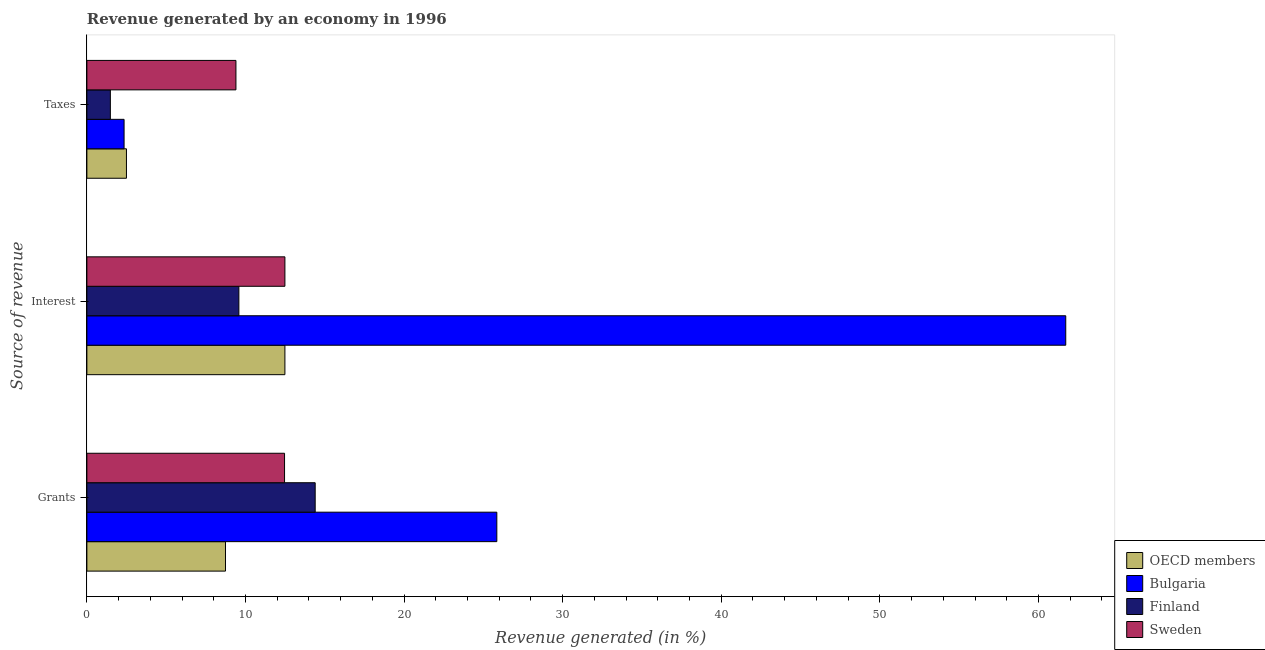How many groups of bars are there?
Your response must be concise. 3. Are the number of bars per tick equal to the number of legend labels?
Offer a very short reply. Yes. Are the number of bars on each tick of the Y-axis equal?
Your answer should be very brief. Yes. How many bars are there on the 1st tick from the top?
Your answer should be compact. 4. How many bars are there on the 1st tick from the bottom?
Your answer should be very brief. 4. What is the label of the 2nd group of bars from the top?
Make the answer very short. Interest. What is the percentage of revenue generated by grants in Sweden?
Give a very brief answer. 12.46. Across all countries, what is the maximum percentage of revenue generated by interest?
Offer a terse response. 61.72. Across all countries, what is the minimum percentage of revenue generated by taxes?
Offer a terse response. 1.48. In which country was the percentage of revenue generated by grants minimum?
Your response must be concise. OECD members. What is the total percentage of revenue generated by interest in the graph?
Provide a short and direct response. 96.28. What is the difference between the percentage of revenue generated by grants in OECD members and that in Sweden?
Your answer should be compact. -3.72. What is the difference between the percentage of revenue generated by interest in Sweden and the percentage of revenue generated by grants in Finland?
Give a very brief answer. -1.91. What is the average percentage of revenue generated by taxes per country?
Provide a short and direct response. 3.93. What is the difference between the percentage of revenue generated by grants and percentage of revenue generated by taxes in Bulgaria?
Your response must be concise. 23.5. What is the ratio of the percentage of revenue generated by grants in Sweden to that in Finland?
Offer a very short reply. 0.87. What is the difference between the highest and the second highest percentage of revenue generated by taxes?
Keep it short and to the point. 6.9. What is the difference between the highest and the lowest percentage of revenue generated by taxes?
Offer a terse response. 7.92. What does the 1st bar from the top in Grants represents?
Give a very brief answer. Sweden. Is it the case that in every country, the sum of the percentage of revenue generated by grants and percentage of revenue generated by interest is greater than the percentage of revenue generated by taxes?
Provide a short and direct response. Yes. How many bars are there?
Offer a very short reply. 12. Are all the bars in the graph horizontal?
Offer a terse response. Yes. How many countries are there in the graph?
Your answer should be compact. 4. Are the values on the major ticks of X-axis written in scientific E-notation?
Offer a very short reply. No. Does the graph contain any zero values?
Provide a short and direct response. No. How many legend labels are there?
Your response must be concise. 4. How are the legend labels stacked?
Keep it short and to the point. Vertical. What is the title of the graph?
Your answer should be compact. Revenue generated by an economy in 1996. What is the label or title of the X-axis?
Keep it short and to the point. Revenue generated (in %). What is the label or title of the Y-axis?
Offer a very short reply. Source of revenue. What is the Revenue generated (in %) of OECD members in Grants?
Your response must be concise. 8.74. What is the Revenue generated (in %) of Bulgaria in Grants?
Give a very brief answer. 25.85. What is the Revenue generated (in %) of Finland in Grants?
Offer a very short reply. 14.4. What is the Revenue generated (in %) of Sweden in Grants?
Keep it short and to the point. 12.46. What is the Revenue generated (in %) in OECD members in Interest?
Your answer should be compact. 12.49. What is the Revenue generated (in %) in Bulgaria in Interest?
Your answer should be compact. 61.72. What is the Revenue generated (in %) in Finland in Interest?
Your response must be concise. 9.58. What is the Revenue generated (in %) in Sweden in Interest?
Your answer should be very brief. 12.49. What is the Revenue generated (in %) of OECD members in Taxes?
Give a very brief answer. 2.5. What is the Revenue generated (in %) in Bulgaria in Taxes?
Your answer should be compact. 2.35. What is the Revenue generated (in %) of Finland in Taxes?
Provide a short and direct response. 1.48. What is the Revenue generated (in %) of Sweden in Taxes?
Ensure brevity in your answer.  9.4. Across all Source of revenue, what is the maximum Revenue generated (in %) of OECD members?
Keep it short and to the point. 12.49. Across all Source of revenue, what is the maximum Revenue generated (in %) in Bulgaria?
Provide a succinct answer. 61.72. Across all Source of revenue, what is the maximum Revenue generated (in %) of Finland?
Ensure brevity in your answer.  14.4. Across all Source of revenue, what is the maximum Revenue generated (in %) in Sweden?
Provide a succinct answer. 12.49. Across all Source of revenue, what is the minimum Revenue generated (in %) of OECD members?
Give a very brief answer. 2.5. Across all Source of revenue, what is the minimum Revenue generated (in %) in Bulgaria?
Your answer should be very brief. 2.35. Across all Source of revenue, what is the minimum Revenue generated (in %) of Finland?
Your response must be concise. 1.48. Across all Source of revenue, what is the minimum Revenue generated (in %) of Sweden?
Your answer should be very brief. 9.4. What is the total Revenue generated (in %) in OECD members in the graph?
Offer a terse response. 23.72. What is the total Revenue generated (in %) in Bulgaria in the graph?
Ensure brevity in your answer.  89.92. What is the total Revenue generated (in %) of Finland in the graph?
Your answer should be compact. 25.46. What is the total Revenue generated (in %) in Sweden in the graph?
Your response must be concise. 34.35. What is the difference between the Revenue generated (in %) of OECD members in Grants and that in Interest?
Ensure brevity in your answer.  -3.75. What is the difference between the Revenue generated (in %) of Bulgaria in Grants and that in Interest?
Ensure brevity in your answer.  -35.87. What is the difference between the Revenue generated (in %) of Finland in Grants and that in Interest?
Ensure brevity in your answer.  4.81. What is the difference between the Revenue generated (in %) of Sweden in Grants and that in Interest?
Provide a succinct answer. -0.02. What is the difference between the Revenue generated (in %) of OECD members in Grants and that in Taxes?
Your answer should be compact. 6.24. What is the difference between the Revenue generated (in %) in Bulgaria in Grants and that in Taxes?
Make the answer very short. 23.5. What is the difference between the Revenue generated (in %) of Finland in Grants and that in Taxes?
Give a very brief answer. 12.91. What is the difference between the Revenue generated (in %) in Sweden in Grants and that in Taxes?
Ensure brevity in your answer.  3.06. What is the difference between the Revenue generated (in %) in OECD members in Interest and that in Taxes?
Your answer should be compact. 9.99. What is the difference between the Revenue generated (in %) in Bulgaria in Interest and that in Taxes?
Make the answer very short. 59.38. What is the difference between the Revenue generated (in %) in Finland in Interest and that in Taxes?
Offer a very short reply. 8.1. What is the difference between the Revenue generated (in %) of Sweden in Interest and that in Taxes?
Your answer should be compact. 3.09. What is the difference between the Revenue generated (in %) of OECD members in Grants and the Revenue generated (in %) of Bulgaria in Interest?
Provide a succinct answer. -52.98. What is the difference between the Revenue generated (in %) of OECD members in Grants and the Revenue generated (in %) of Finland in Interest?
Your answer should be very brief. -0.84. What is the difference between the Revenue generated (in %) in OECD members in Grants and the Revenue generated (in %) in Sweden in Interest?
Your response must be concise. -3.75. What is the difference between the Revenue generated (in %) of Bulgaria in Grants and the Revenue generated (in %) of Finland in Interest?
Keep it short and to the point. 16.26. What is the difference between the Revenue generated (in %) of Bulgaria in Grants and the Revenue generated (in %) of Sweden in Interest?
Provide a succinct answer. 13.36. What is the difference between the Revenue generated (in %) of Finland in Grants and the Revenue generated (in %) of Sweden in Interest?
Make the answer very short. 1.91. What is the difference between the Revenue generated (in %) of OECD members in Grants and the Revenue generated (in %) of Bulgaria in Taxes?
Your answer should be very brief. 6.39. What is the difference between the Revenue generated (in %) of OECD members in Grants and the Revenue generated (in %) of Finland in Taxes?
Offer a terse response. 7.26. What is the difference between the Revenue generated (in %) in OECD members in Grants and the Revenue generated (in %) in Sweden in Taxes?
Your answer should be very brief. -0.66. What is the difference between the Revenue generated (in %) in Bulgaria in Grants and the Revenue generated (in %) in Finland in Taxes?
Your response must be concise. 24.37. What is the difference between the Revenue generated (in %) of Bulgaria in Grants and the Revenue generated (in %) of Sweden in Taxes?
Your answer should be compact. 16.45. What is the difference between the Revenue generated (in %) of Finland in Grants and the Revenue generated (in %) of Sweden in Taxes?
Give a very brief answer. 5. What is the difference between the Revenue generated (in %) of OECD members in Interest and the Revenue generated (in %) of Bulgaria in Taxes?
Provide a succinct answer. 10.14. What is the difference between the Revenue generated (in %) of OECD members in Interest and the Revenue generated (in %) of Finland in Taxes?
Your answer should be very brief. 11.01. What is the difference between the Revenue generated (in %) of OECD members in Interest and the Revenue generated (in %) of Sweden in Taxes?
Ensure brevity in your answer.  3.09. What is the difference between the Revenue generated (in %) of Bulgaria in Interest and the Revenue generated (in %) of Finland in Taxes?
Ensure brevity in your answer.  60.24. What is the difference between the Revenue generated (in %) of Bulgaria in Interest and the Revenue generated (in %) of Sweden in Taxes?
Offer a terse response. 52.32. What is the difference between the Revenue generated (in %) in Finland in Interest and the Revenue generated (in %) in Sweden in Taxes?
Your response must be concise. 0.19. What is the average Revenue generated (in %) of OECD members per Source of revenue?
Provide a short and direct response. 7.91. What is the average Revenue generated (in %) of Bulgaria per Source of revenue?
Your answer should be compact. 29.97. What is the average Revenue generated (in %) in Finland per Source of revenue?
Keep it short and to the point. 8.49. What is the average Revenue generated (in %) of Sweden per Source of revenue?
Give a very brief answer. 11.45. What is the difference between the Revenue generated (in %) of OECD members and Revenue generated (in %) of Bulgaria in Grants?
Provide a succinct answer. -17.11. What is the difference between the Revenue generated (in %) of OECD members and Revenue generated (in %) of Finland in Grants?
Make the answer very short. -5.66. What is the difference between the Revenue generated (in %) in OECD members and Revenue generated (in %) in Sweden in Grants?
Offer a very short reply. -3.72. What is the difference between the Revenue generated (in %) of Bulgaria and Revenue generated (in %) of Finland in Grants?
Give a very brief answer. 11.45. What is the difference between the Revenue generated (in %) in Bulgaria and Revenue generated (in %) in Sweden in Grants?
Ensure brevity in your answer.  13.39. What is the difference between the Revenue generated (in %) in Finland and Revenue generated (in %) in Sweden in Grants?
Keep it short and to the point. 1.93. What is the difference between the Revenue generated (in %) of OECD members and Revenue generated (in %) of Bulgaria in Interest?
Keep it short and to the point. -49.23. What is the difference between the Revenue generated (in %) of OECD members and Revenue generated (in %) of Finland in Interest?
Make the answer very short. 2.9. What is the difference between the Revenue generated (in %) in Bulgaria and Revenue generated (in %) in Finland in Interest?
Your response must be concise. 52.14. What is the difference between the Revenue generated (in %) of Bulgaria and Revenue generated (in %) of Sweden in Interest?
Make the answer very short. 49.23. What is the difference between the Revenue generated (in %) of Finland and Revenue generated (in %) of Sweden in Interest?
Offer a very short reply. -2.9. What is the difference between the Revenue generated (in %) in OECD members and Revenue generated (in %) in Bulgaria in Taxes?
Provide a short and direct response. 0.15. What is the difference between the Revenue generated (in %) of OECD members and Revenue generated (in %) of Finland in Taxes?
Your answer should be compact. 1.01. What is the difference between the Revenue generated (in %) in OECD members and Revenue generated (in %) in Sweden in Taxes?
Your answer should be compact. -6.9. What is the difference between the Revenue generated (in %) in Bulgaria and Revenue generated (in %) in Finland in Taxes?
Your answer should be compact. 0.86. What is the difference between the Revenue generated (in %) of Bulgaria and Revenue generated (in %) of Sweden in Taxes?
Keep it short and to the point. -7.05. What is the difference between the Revenue generated (in %) in Finland and Revenue generated (in %) in Sweden in Taxes?
Keep it short and to the point. -7.92. What is the ratio of the Revenue generated (in %) of OECD members in Grants to that in Interest?
Provide a short and direct response. 0.7. What is the ratio of the Revenue generated (in %) in Bulgaria in Grants to that in Interest?
Your answer should be very brief. 0.42. What is the ratio of the Revenue generated (in %) of Finland in Grants to that in Interest?
Your answer should be very brief. 1.5. What is the ratio of the Revenue generated (in %) of Sweden in Grants to that in Interest?
Give a very brief answer. 1. What is the ratio of the Revenue generated (in %) of OECD members in Grants to that in Taxes?
Offer a terse response. 3.5. What is the ratio of the Revenue generated (in %) in Bulgaria in Grants to that in Taxes?
Your answer should be very brief. 11.02. What is the ratio of the Revenue generated (in %) in Finland in Grants to that in Taxes?
Your answer should be compact. 9.72. What is the ratio of the Revenue generated (in %) in Sweden in Grants to that in Taxes?
Ensure brevity in your answer.  1.33. What is the ratio of the Revenue generated (in %) in OECD members in Interest to that in Taxes?
Your answer should be very brief. 5. What is the ratio of the Revenue generated (in %) in Bulgaria in Interest to that in Taxes?
Keep it short and to the point. 26.31. What is the ratio of the Revenue generated (in %) in Finland in Interest to that in Taxes?
Your answer should be compact. 6.47. What is the ratio of the Revenue generated (in %) in Sweden in Interest to that in Taxes?
Offer a terse response. 1.33. What is the difference between the highest and the second highest Revenue generated (in %) in OECD members?
Ensure brevity in your answer.  3.75. What is the difference between the highest and the second highest Revenue generated (in %) of Bulgaria?
Your answer should be very brief. 35.87. What is the difference between the highest and the second highest Revenue generated (in %) of Finland?
Ensure brevity in your answer.  4.81. What is the difference between the highest and the second highest Revenue generated (in %) in Sweden?
Keep it short and to the point. 0.02. What is the difference between the highest and the lowest Revenue generated (in %) of OECD members?
Ensure brevity in your answer.  9.99. What is the difference between the highest and the lowest Revenue generated (in %) of Bulgaria?
Give a very brief answer. 59.38. What is the difference between the highest and the lowest Revenue generated (in %) in Finland?
Your answer should be very brief. 12.91. What is the difference between the highest and the lowest Revenue generated (in %) of Sweden?
Ensure brevity in your answer.  3.09. 